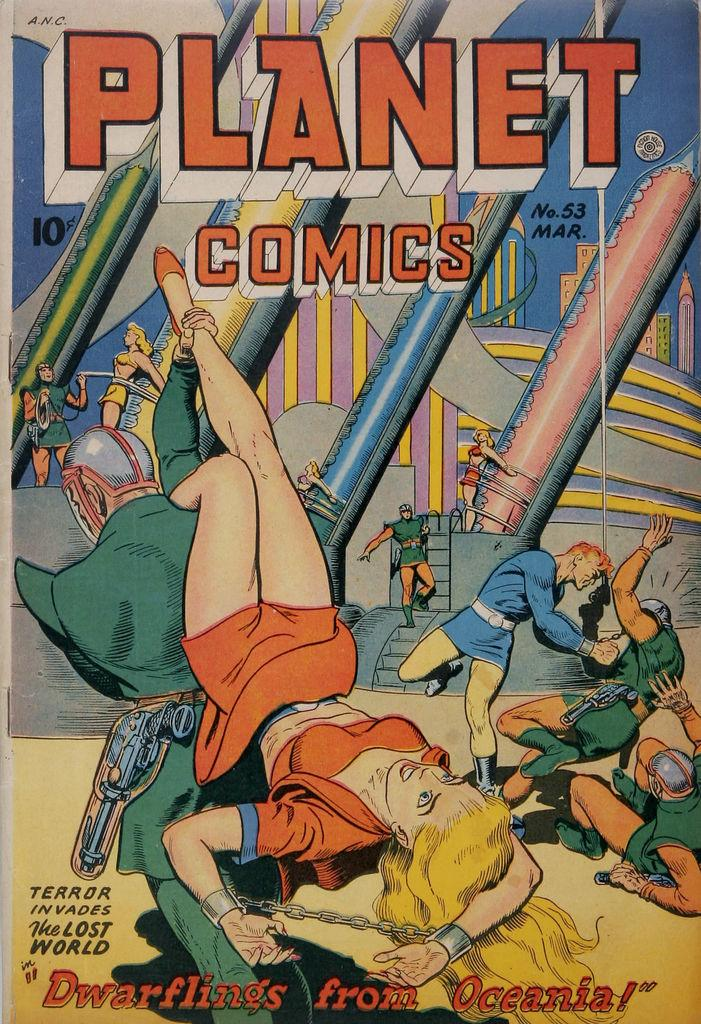Provide a one-sentence caption for the provided image. Planet Comics released issue 53 in March and it cost 10 cents to purchase. 